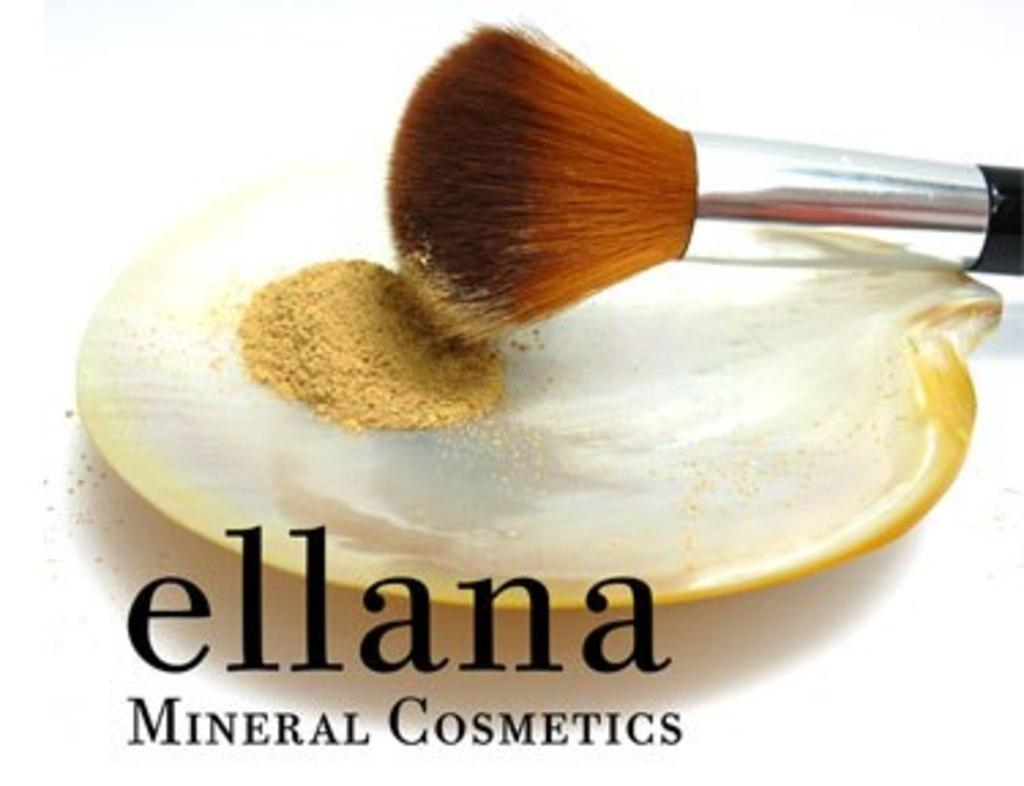<image>
Share a concise interpretation of the image provided. An ad for ellana mineral cosmetics that shows some makeup and a makeup brush. 